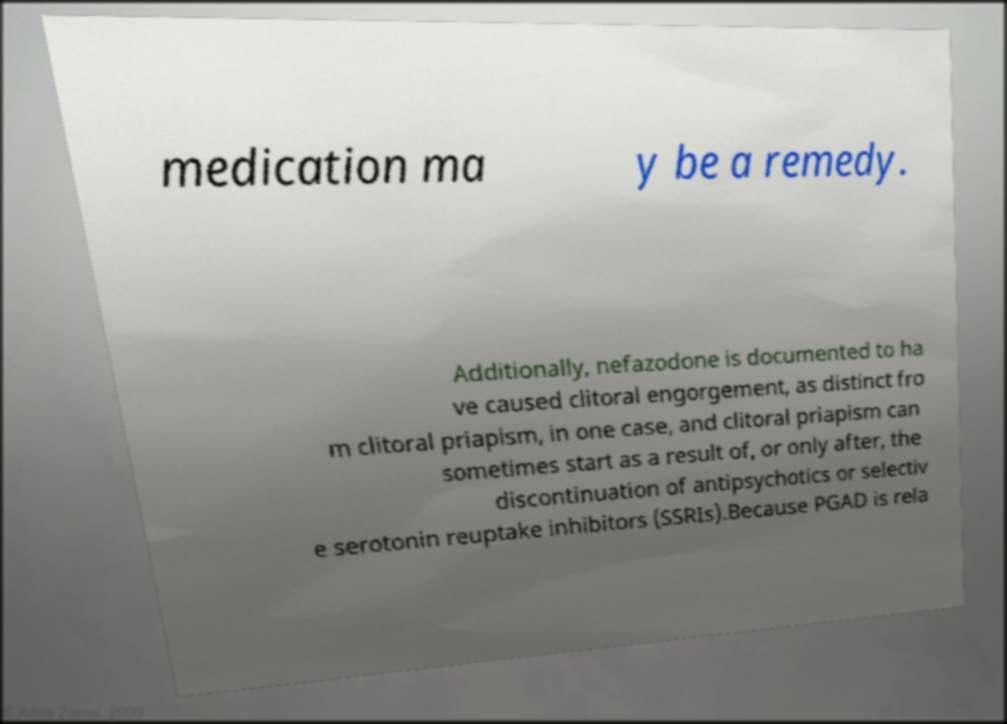I need the written content from this picture converted into text. Can you do that? medication ma y be a remedy. Additionally, nefazodone is documented to ha ve caused clitoral engorgement, as distinct fro m clitoral priapism, in one case, and clitoral priapism can sometimes start as a result of, or only after, the discontinuation of antipsychotics or selectiv e serotonin reuptake inhibitors (SSRIs).Because PGAD is rela 